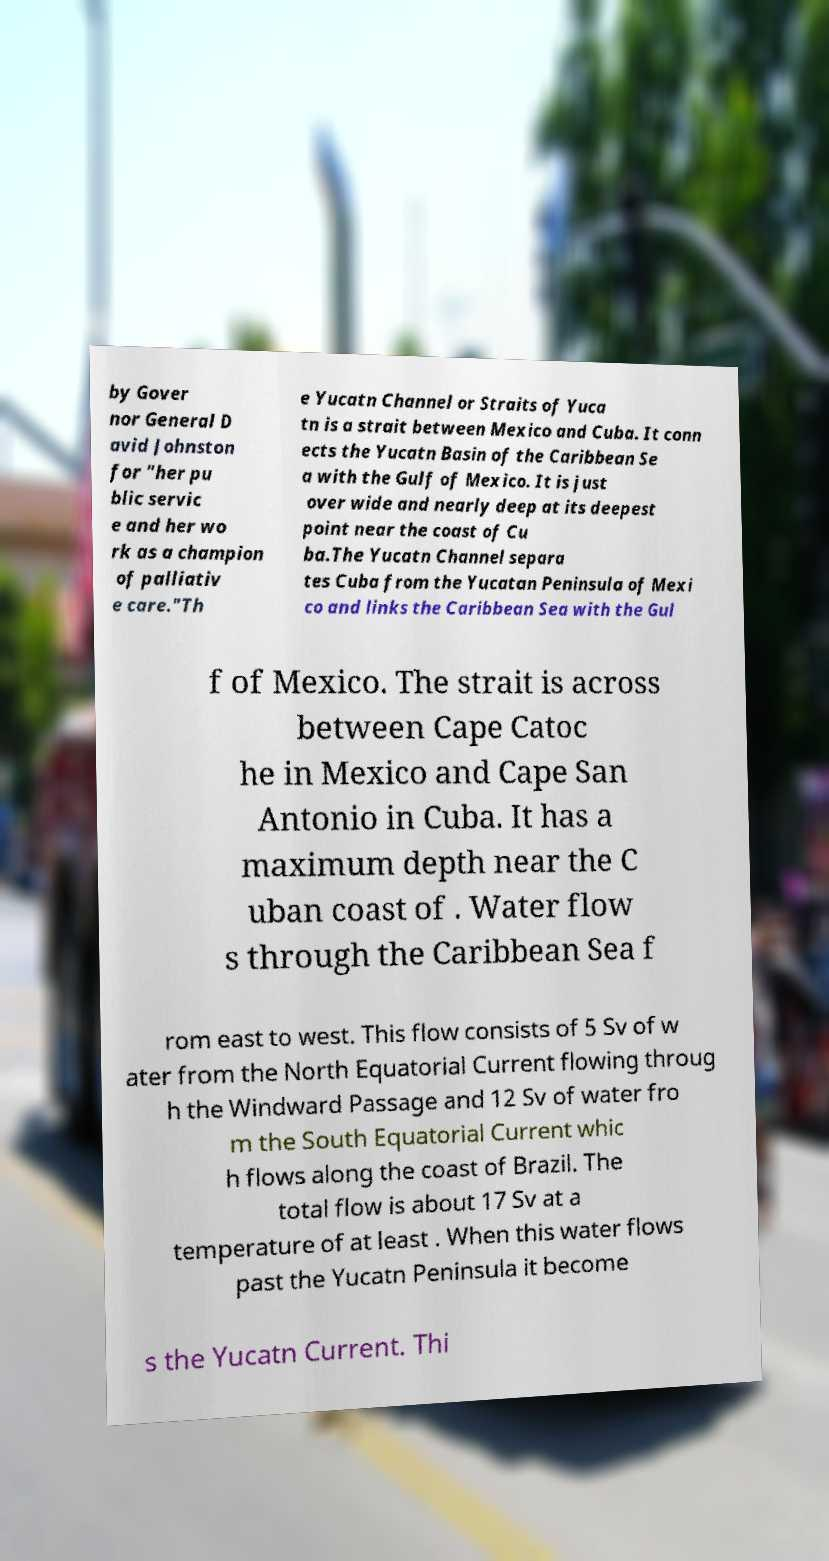Could you assist in decoding the text presented in this image and type it out clearly? by Gover nor General D avid Johnston for "her pu blic servic e and her wo rk as a champion of palliativ e care."Th e Yucatn Channel or Straits of Yuca tn is a strait between Mexico and Cuba. It conn ects the Yucatn Basin of the Caribbean Se a with the Gulf of Mexico. It is just over wide and nearly deep at its deepest point near the coast of Cu ba.The Yucatn Channel separa tes Cuba from the Yucatan Peninsula of Mexi co and links the Caribbean Sea with the Gul f of Mexico. The strait is across between Cape Catoc he in Mexico and Cape San Antonio in Cuba. It has a maximum depth near the C uban coast of . Water flow s through the Caribbean Sea f rom east to west. This flow consists of 5 Sv of w ater from the North Equatorial Current flowing throug h the Windward Passage and 12 Sv of water fro m the South Equatorial Current whic h flows along the coast of Brazil. The total flow is about 17 Sv at a temperature of at least . When this water flows past the Yucatn Peninsula it become s the Yucatn Current. Thi 